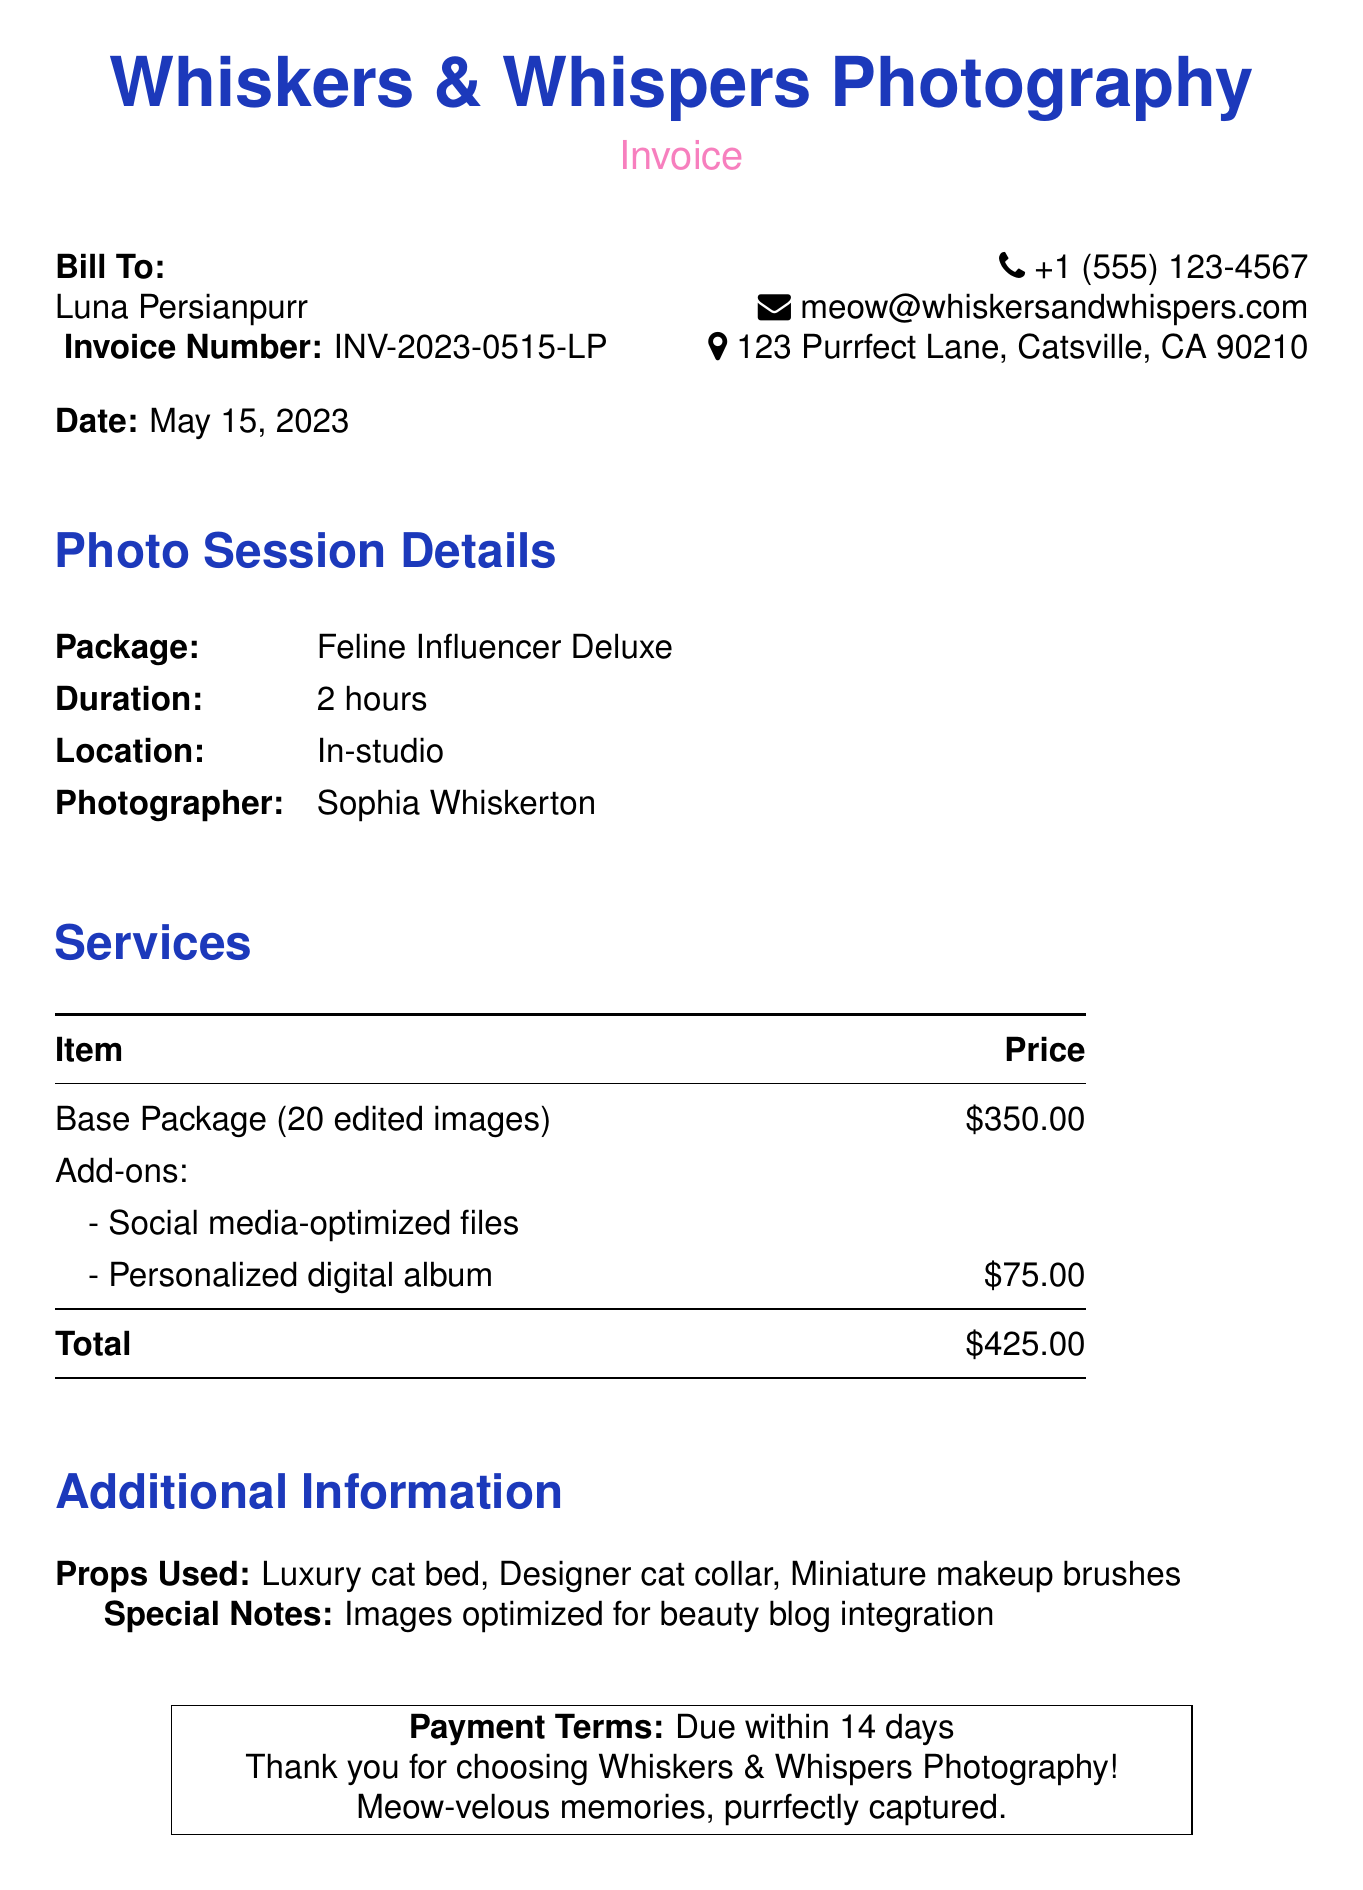What is the invoice number? The invoice number is specified in the document as INV-2023-0515-LP.
Answer: INV-2023-0515-LP Who is the photographer? The document lists Sophia Whiskerton as the photographer for the session.
Answer: Sophia Whiskerton What is the total amount due? The total amount due is the sum of the base package and add-ons, which is $425.00.
Answer: $425.00 How many edited images are included in the package? The package includes 20 edited images as stated in the services section.
Answer: 20 edited images What is the duration of the photo session? The duration of the photo session is mentioned as 2 hours in the document.
Answer: 2 hours What additional service costs $75? The document indicates that a personalized digital album is an additional service costing $75.
Answer: Personalized digital album What are the payment terms? The payment terms specify that payment is due within 14 days after the invoice date.
Answer: Due within 14 days Where is the photo session location? The location for the photo session is stated to be in-studio in the document.
Answer: In-studio What props were used during the photo shoot? The props mentioned in the document include a luxury cat bed, designer cat collar, and miniature makeup brushes.
Answer: Luxury cat bed, designer cat collar, miniature makeup brushes 